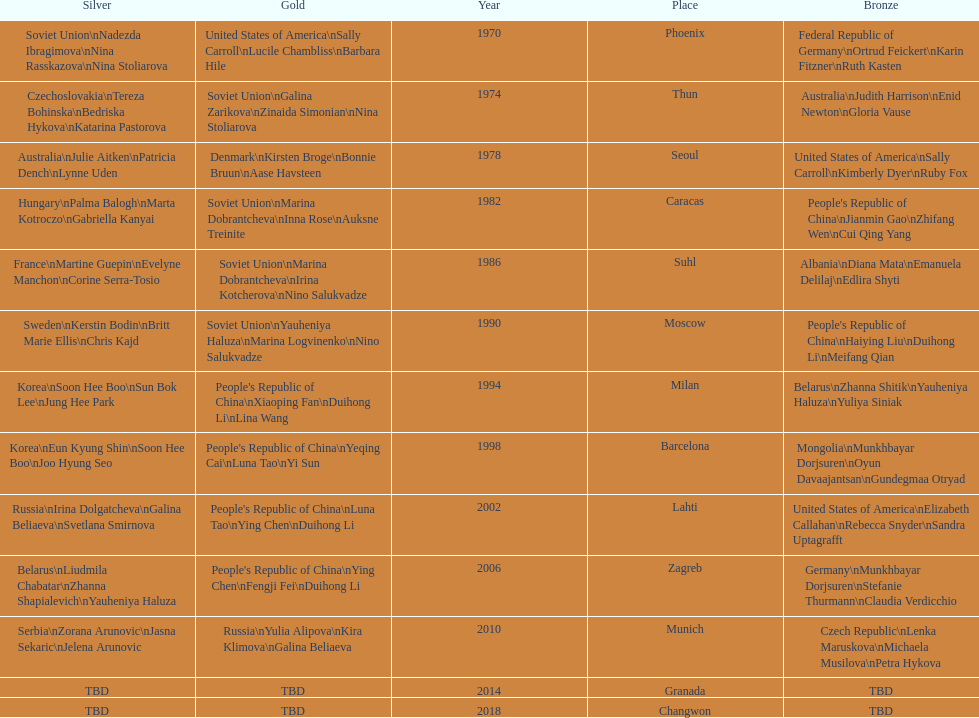How many world championships had the soviet union won first place in in the 25 metre pistol women's world championship? 4. 